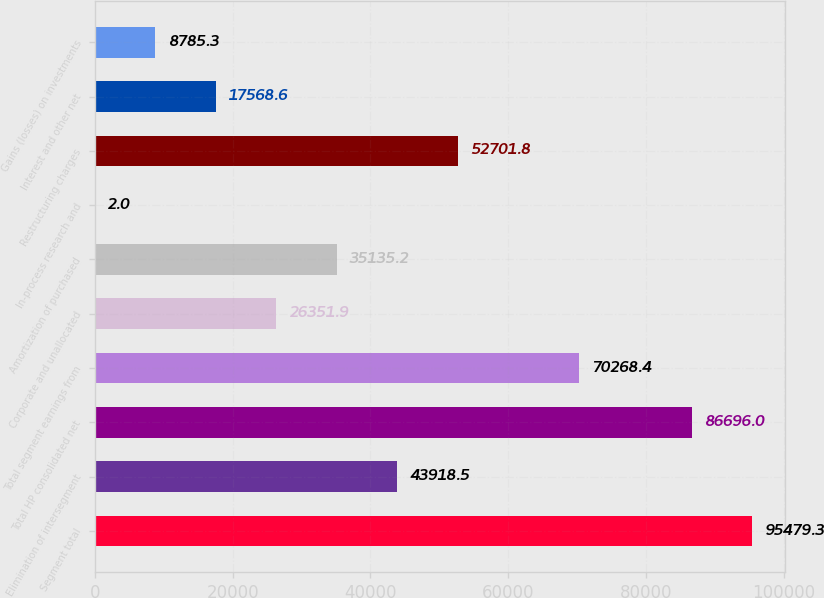<chart> <loc_0><loc_0><loc_500><loc_500><bar_chart><fcel>Segment total<fcel>Elimination of intersegment<fcel>Total HP consolidated net<fcel>Total segment earnings from<fcel>Corporate and unallocated<fcel>Amortization of purchased<fcel>In-process research and<fcel>Restructuring charges<fcel>Interest and other net<fcel>Gains (losses) on investments<nl><fcel>95479.3<fcel>43918.5<fcel>86696<fcel>70268.4<fcel>26351.9<fcel>35135.2<fcel>2<fcel>52701.8<fcel>17568.6<fcel>8785.3<nl></chart> 